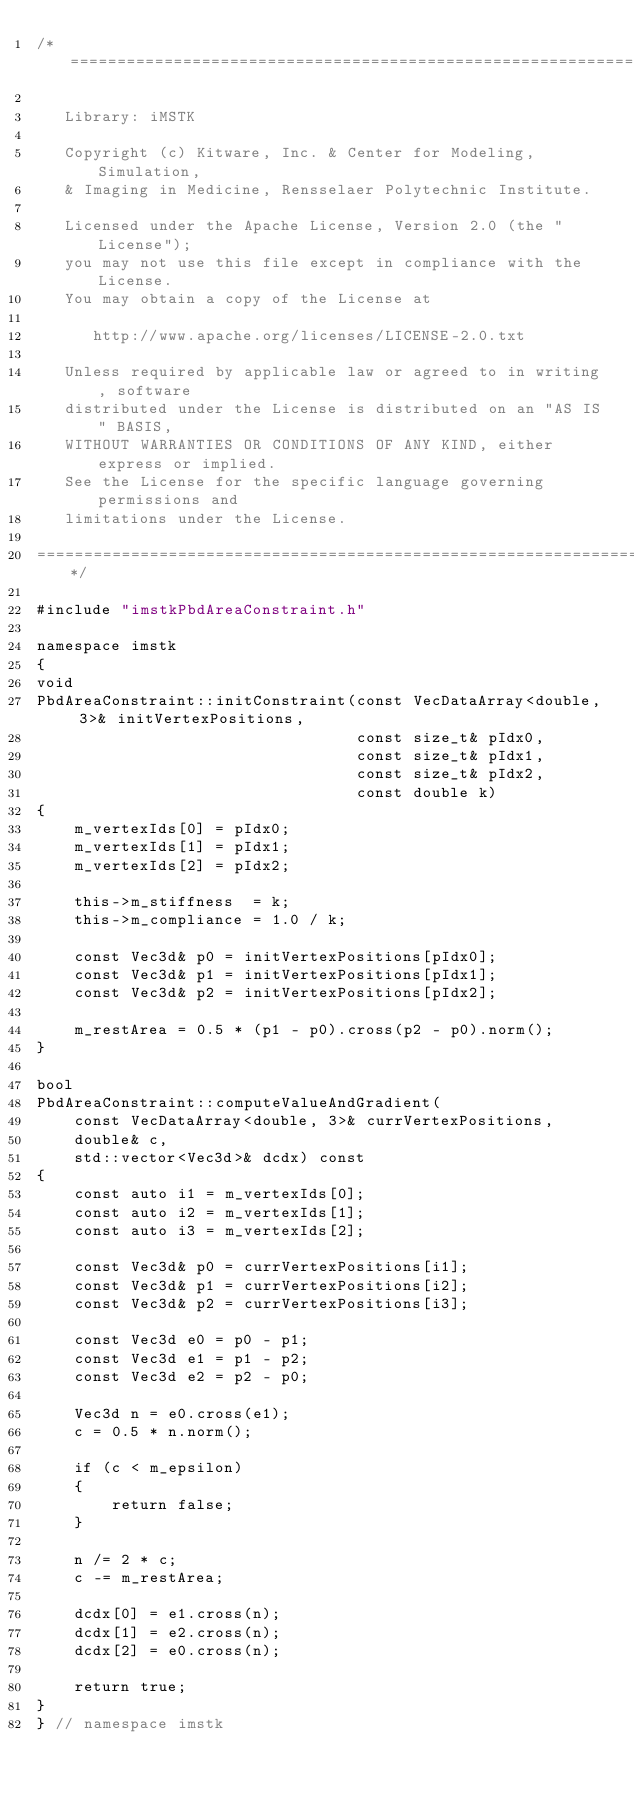<code> <loc_0><loc_0><loc_500><loc_500><_C++_>/*=========================================================================

   Library: iMSTK

   Copyright (c) Kitware, Inc. & Center for Modeling, Simulation,
   & Imaging in Medicine, Rensselaer Polytechnic Institute.

   Licensed under the Apache License, Version 2.0 (the "License");
   you may not use this file except in compliance with the License.
   You may obtain a copy of the License at

      http://www.apache.org/licenses/LICENSE-2.0.txt

   Unless required by applicable law or agreed to in writing, software
   distributed under the License is distributed on an "AS IS" BASIS,
   WITHOUT WARRANTIES OR CONDITIONS OF ANY KIND, either express or implied.
   See the License for the specific language governing permissions and
   limitations under the License.

=========================================================================*/

#include "imstkPbdAreaConstraint.h"

namespace imstk
{
void
PbdAreaConstraint::initConstraint(const VecDataArray<double, 3>& initVertexPositions,
                                  const size_t& pIdx0,
                                  const size_t& pIdx1,
                                  const size_t& pIdx2,
                                  const double k)
{
    m_vertexIds[0] = pIdx0;
    m_vertexIds[1] = pIdx1;
    m_vertexIds[2] = pIdx2;

    this->m_stiffness  = k;
    this->m_compliance = 1.0 / k;

    const Vec3d& p0 = initVertexPositions[pIdx0];
    const Vec3d& p1 = initVertexPositions[pIdx1];
    const Vec3d& p2 = initVertexPositions[pIdx2];

    m_restArea = 0.5 * (p1 - p0).cross(p2 - p0).norm();
}

bool
PbdAreaConstraint::computeValueAndGradient(
    const VecDataArray<double, 3>& currVertexPositions,
    double& c,
    std::vector<Vec3d>& dcdx) const
{
    const auto i1 = m_vertexIds[0];
    const auto i2 = m_vertexIds[1];
    const auto i3 = m_vertexIds[2];

    const Vec3d& p0 = currVertexPositions[i1];
    const Vec3d& p1 = currVertexPositions[i2];
    const Vec3d& p2 = currVertexPositions[i3];

    const Vec3d e0 = p0 - p1;
    const Vec3d e1 = p1 - p2;
    const Vec3d e2 = p2 - p0;

    Vec3d n = e0.cross(e1);
    c = 0.5 * n.norm();

    if (c < m_epsilon)
    {
        return false;
    }

    n /= 2 * c;
    c -= m_restArea;

    dcdx[0] = e1.cross(n);
    dcdx[1] = e2.cross(n);
    dcdx[2] = e0.cross(n);

    return true;
}
} // namespace imstk
</code> 